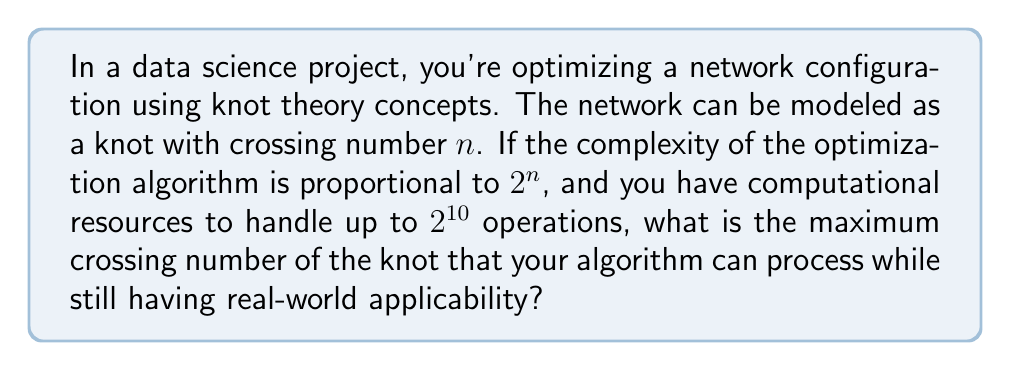What is the answer to this math problem? Let's approach this step-by-step:

1) The complexity of the algorithm is given as $2^n$, where $n$ is the crossing number of the knot.

2) We're told that the computational resources can handle up to $2^{10}$ operations.

3) To find the maximum crossing number, we need to solve the equation:

   $$2^n = 2^{10}$$

4) Taking the logarithm (base 2) of both sides:

   $$\log_2(2^n) = \log_2(2^{10})$$

5) Simplifying:

   $$n = 10$$

6) Therefore, the maximum crossing number that can be processed is 10.

7) From a real-world applicability perspective, this means that network configurations modeled by knots with up to 10 crossings can be optimized using this algorithm within the given computational constraints.
Answer: 10 